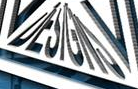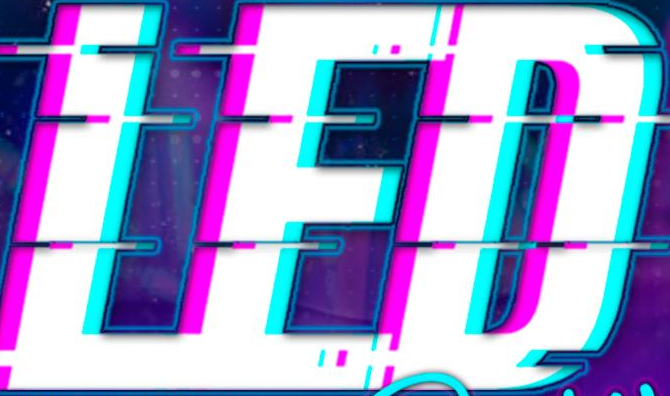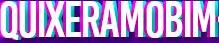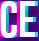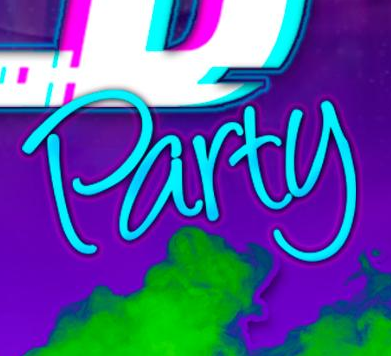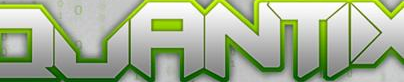What text appears in these images from left to right, separated by a semicolon? DESIGNS; LED; QUIXERAMOBIM; CE; Party; QUANTIX 